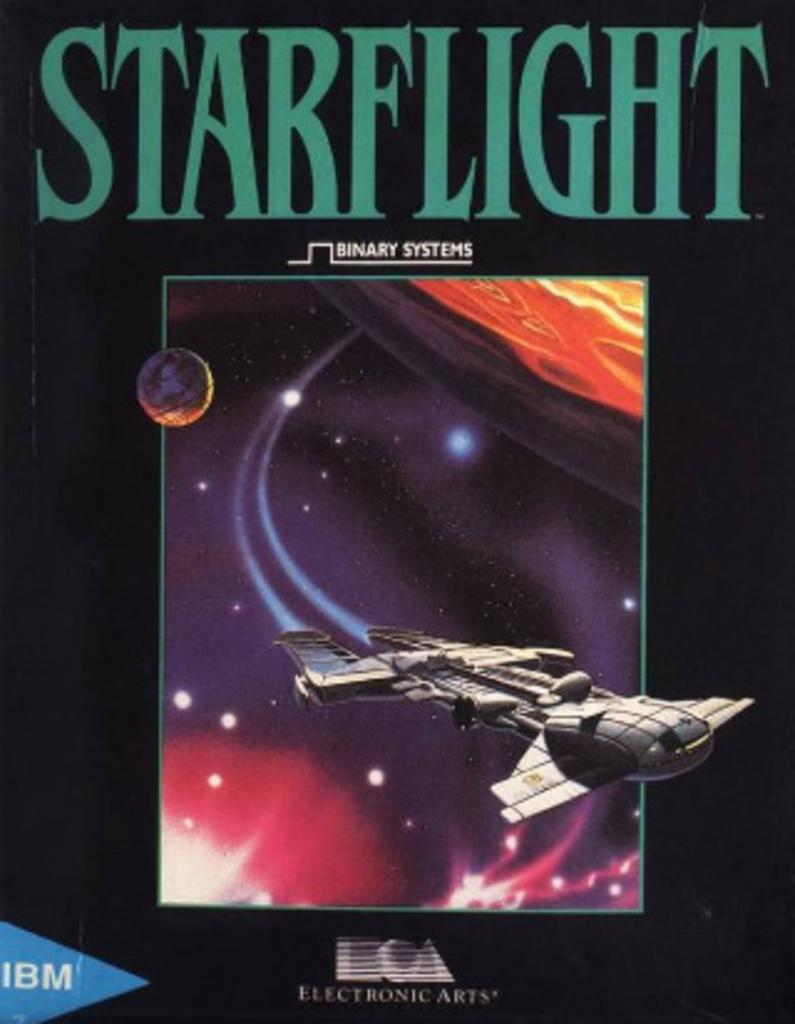<image>
Present a compact description of the photo's key features. A Starflight binary systems Electronic Arts by IBM cover. 